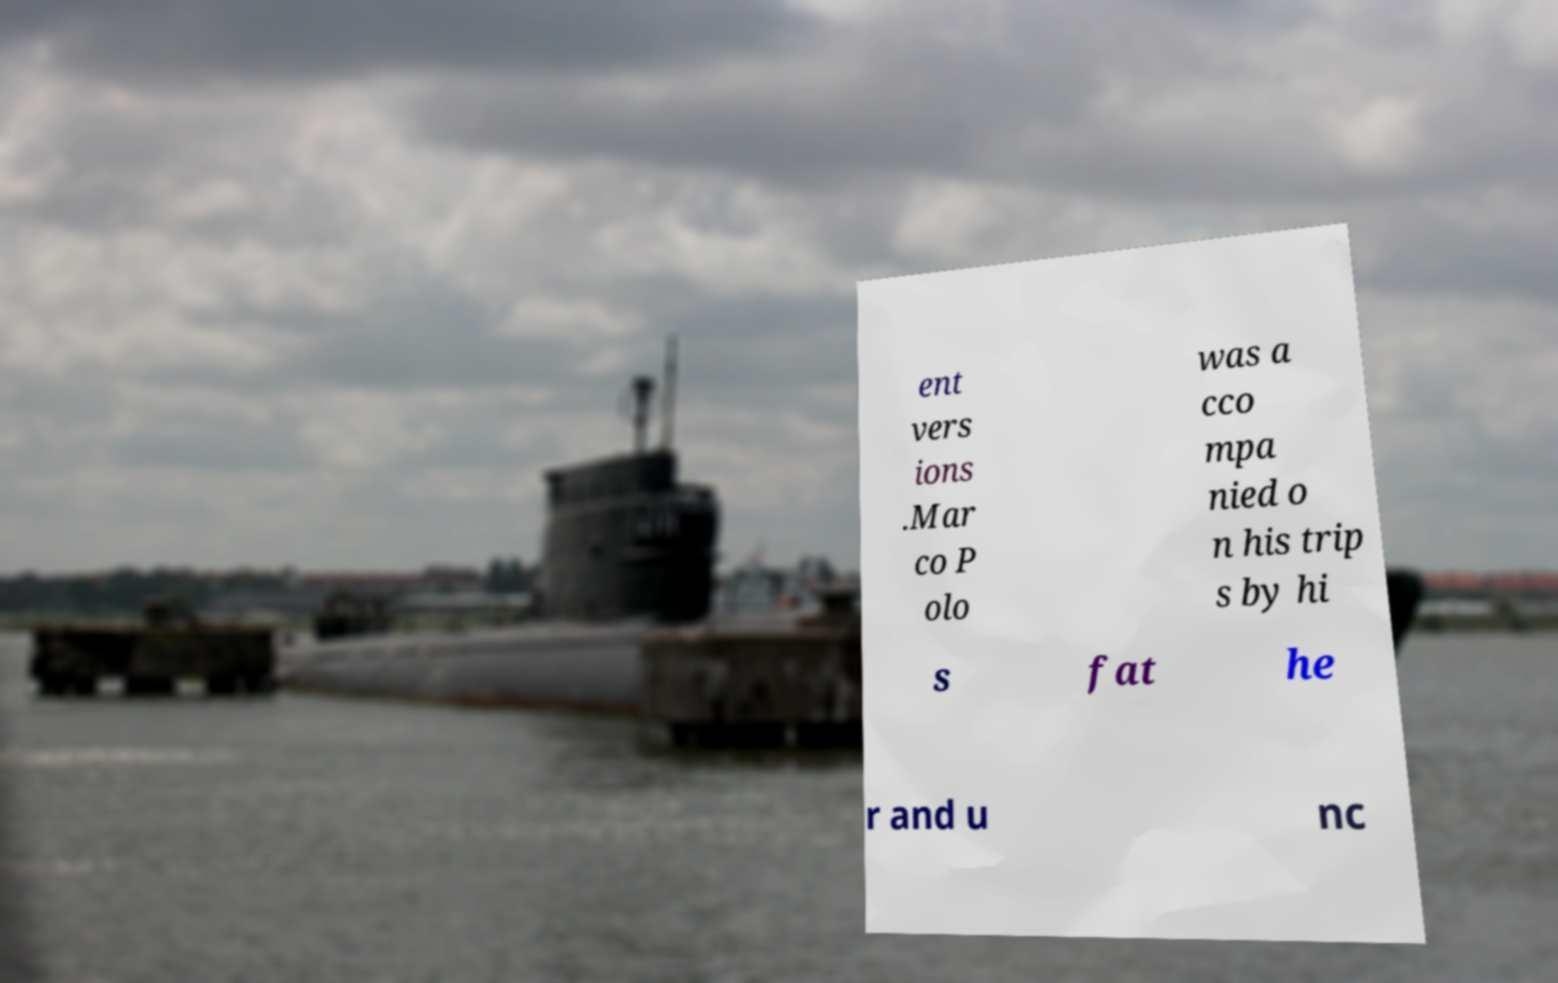What messages or text are displayed in this image? I need them in a readable, typed format. ent vers ions .Mar co P olo was a cco mpa nied o n his trip s by hi s fat he r and u nc 